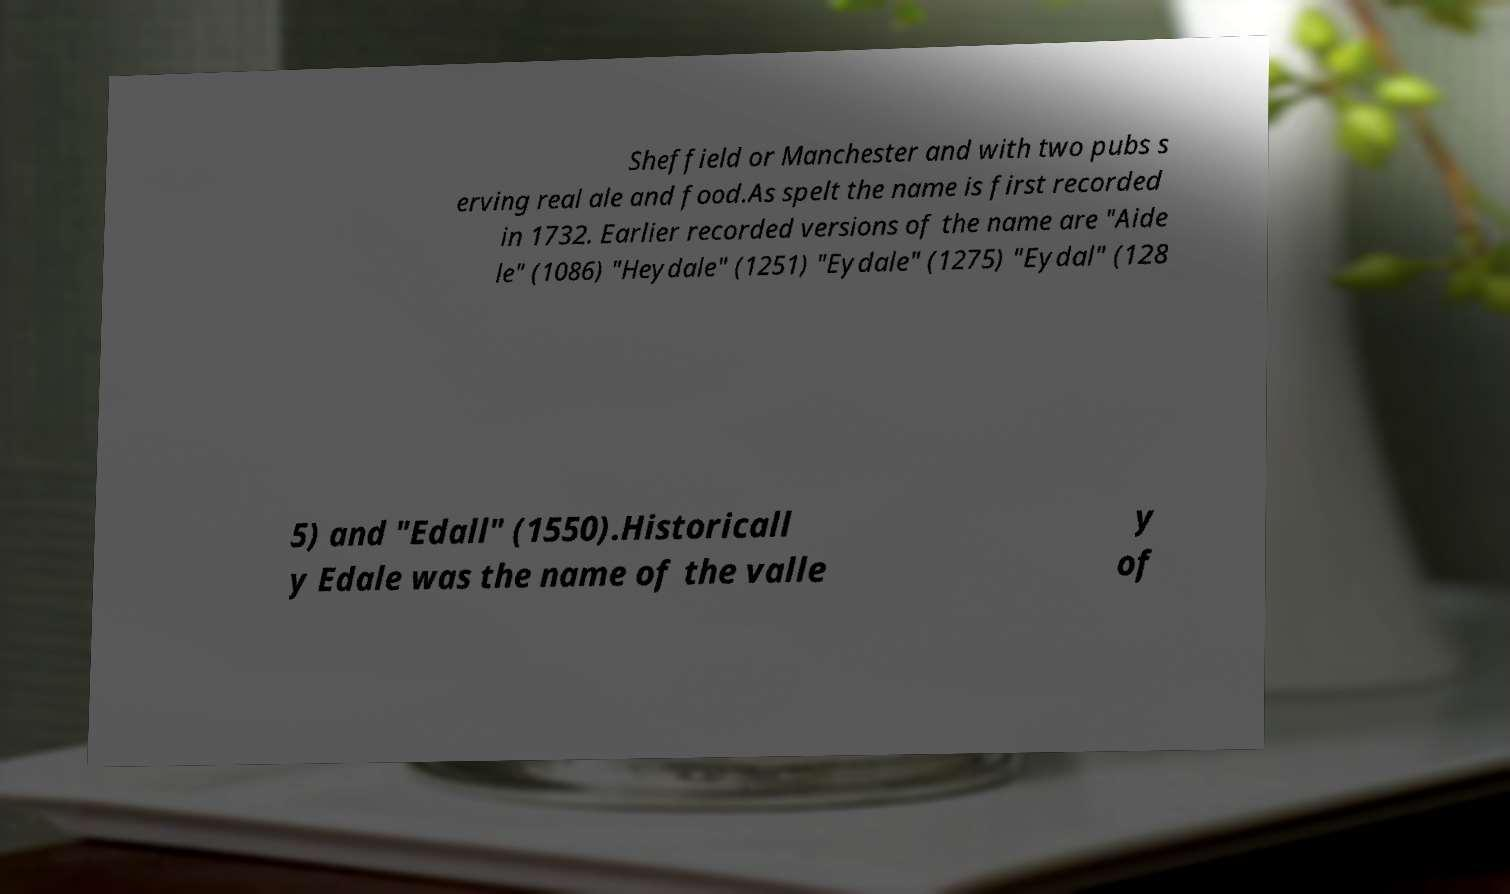Could you assist in decoding the text presented in this image and type it out clearly? Sheffield or Manchester and with two pubs s erving real ale and food.As spelt the name is first recorded in 1732. Earlier recorded versions of the name are "Aide le" (1086) "Heydale" (1251) "Eydale" (1275) "Eydal" (128 5) and "Edall" (1550).Historicall y Edale was the name of the valle y of 